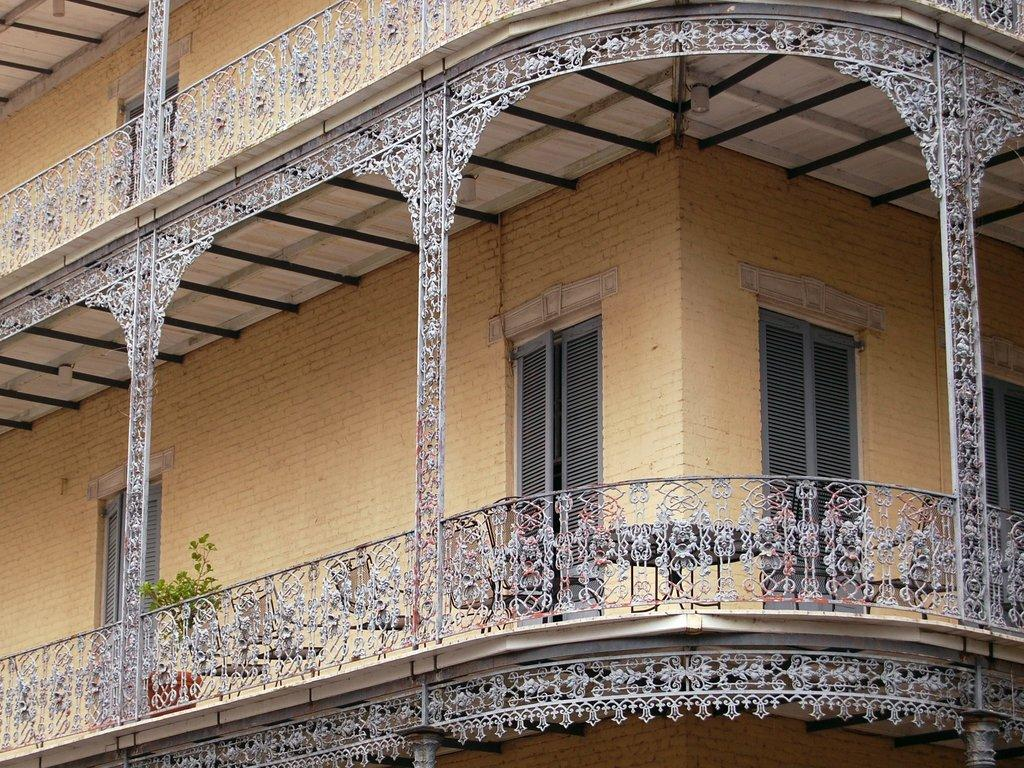What type of structure is present in the image? There is a building in the image. What feature of the building is mentioned in the facts? The building has doors. Are there any natural elements present in the image? Yes, there is a plant in the image. What can be seen at the top of the image? There are lights visible at the top of the image. Can you tell me how many railway tracks are visible in the image? There are no railway tracks present in the image. What type of ball is being used in the game depicted in the image? There is no game or ball depicted in the image. 